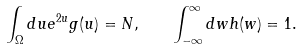<formula> <loc_0><loc_0><loc_500><loc_500>\int _ { \Omega } d u e ^ { 2 u } g ( u ) = N , \quad \int _ { - \infty } ^ { \infty } d w h ( w ) = 1 .</formula> 